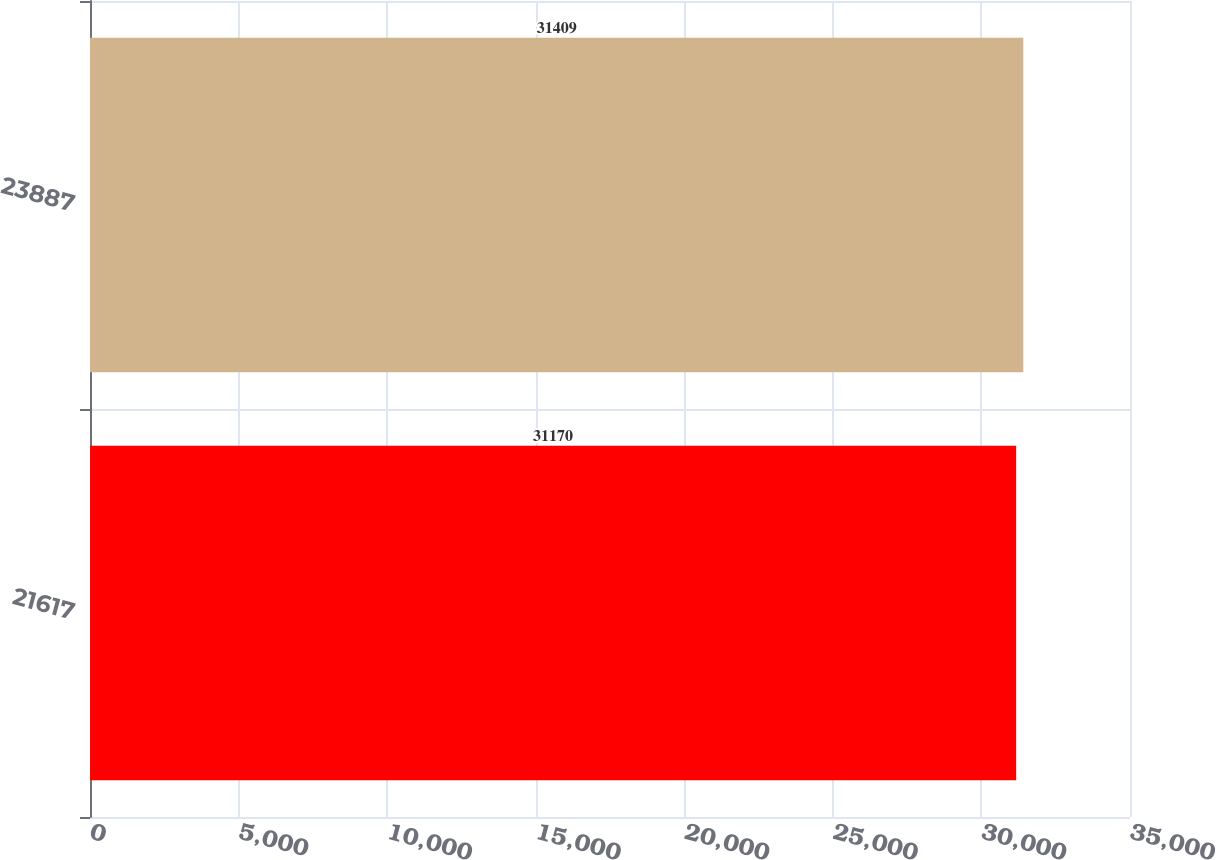Convert chart. <chart><loc_0><loc_0><loc_500><loc_500><bar_chart><fcel>21617<fcel>23887<nl><fcel>31170<fcel>31409<nl></chart> 